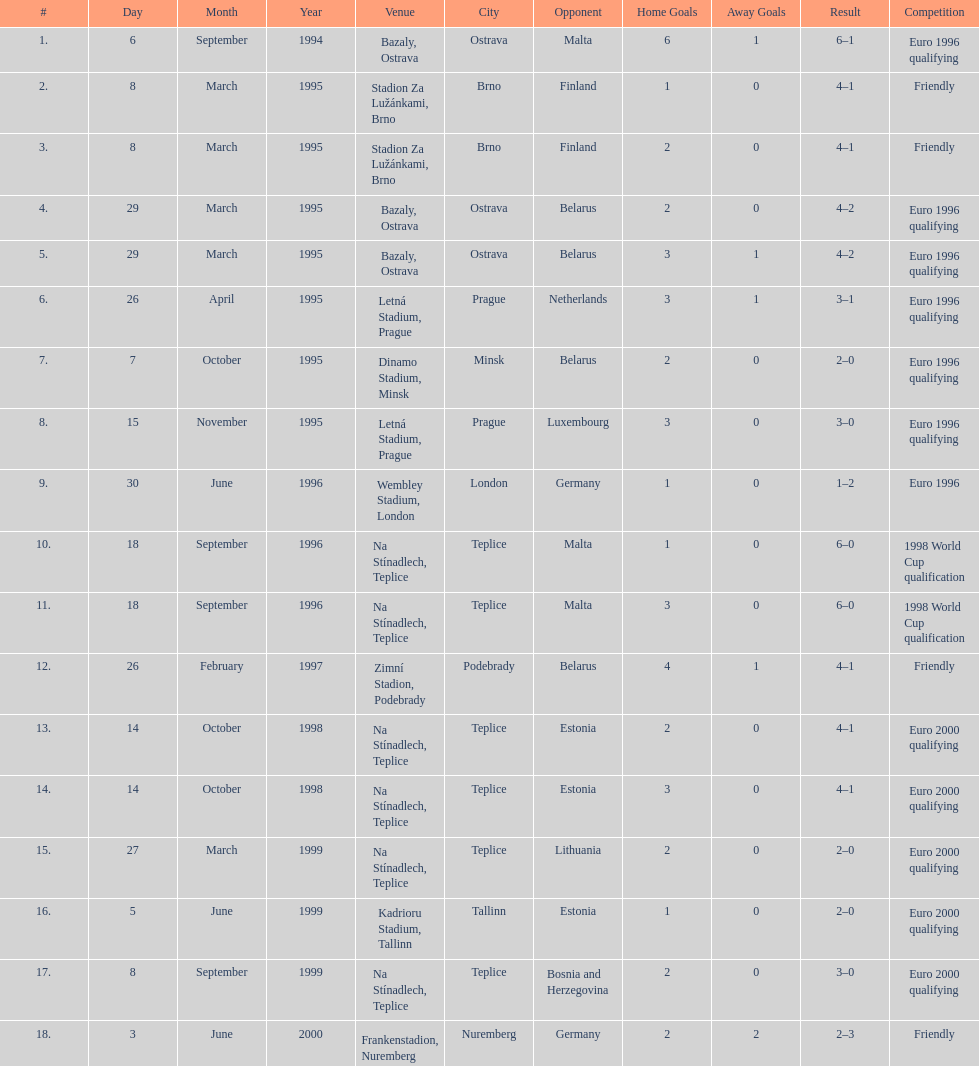What venue is listed above wembley stadium, london? Letná Stadium, Prague. 